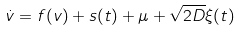<formula> <loc_0><loc_0><loc_500><loc_500>\dot { v } = f ( v ) + s ( t ) + \mu + \sqrt { 2 D } \xi ( t )</formula> 